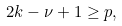Convert formula to latex. <formula><loc_0><loc_0><loc_500><loc_500>2 k - \nu + 1 \geq p ,</formula> 